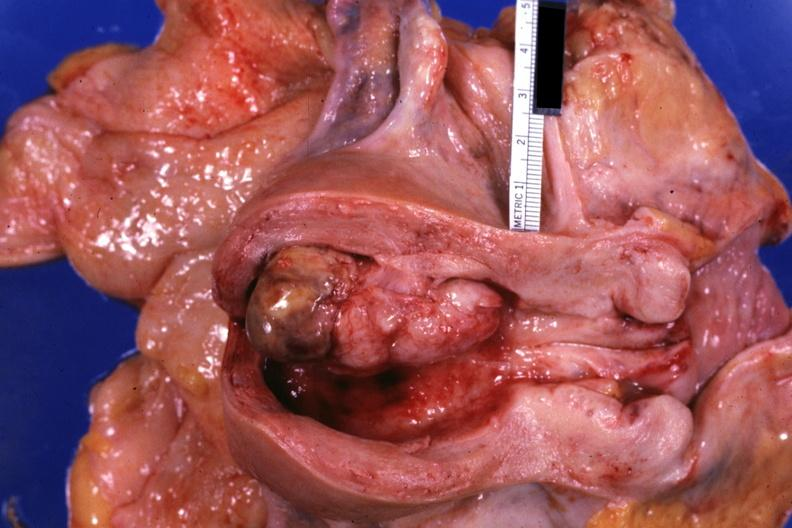s mixed mesodermal tumor present?
Answer the question using a single word or phrase. Yes 